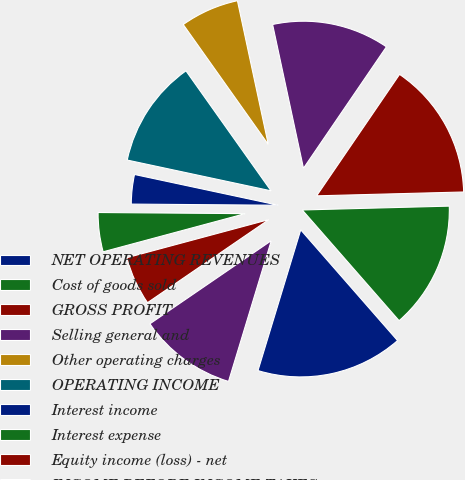Convert chart to OTSL. <chart><loc_0><loc_0><loc_500><loc_500><pie_chart><fcel>NET OPERATING REVENUES<fcel>Cost of goods sold<fcel>GROSS PROFIT<fcel>Selling general and<fcel>Other operating charges<fcel>OPERATING INCOME<fcel>Interest income<fcel>Interest expense<fcel>Equity income (loss) - net<fcel>INCOME BEFORE INCOME TAXES<nl><fcel>16.13%<fcel>13.98%<fcel>15.05%<fcel>12.9%<fcel>6.45%<fcel>11.83%<fcel>3.23%<fcel>4.3%<fcel>5.38%<fcel>10.75%<nl></chart> 